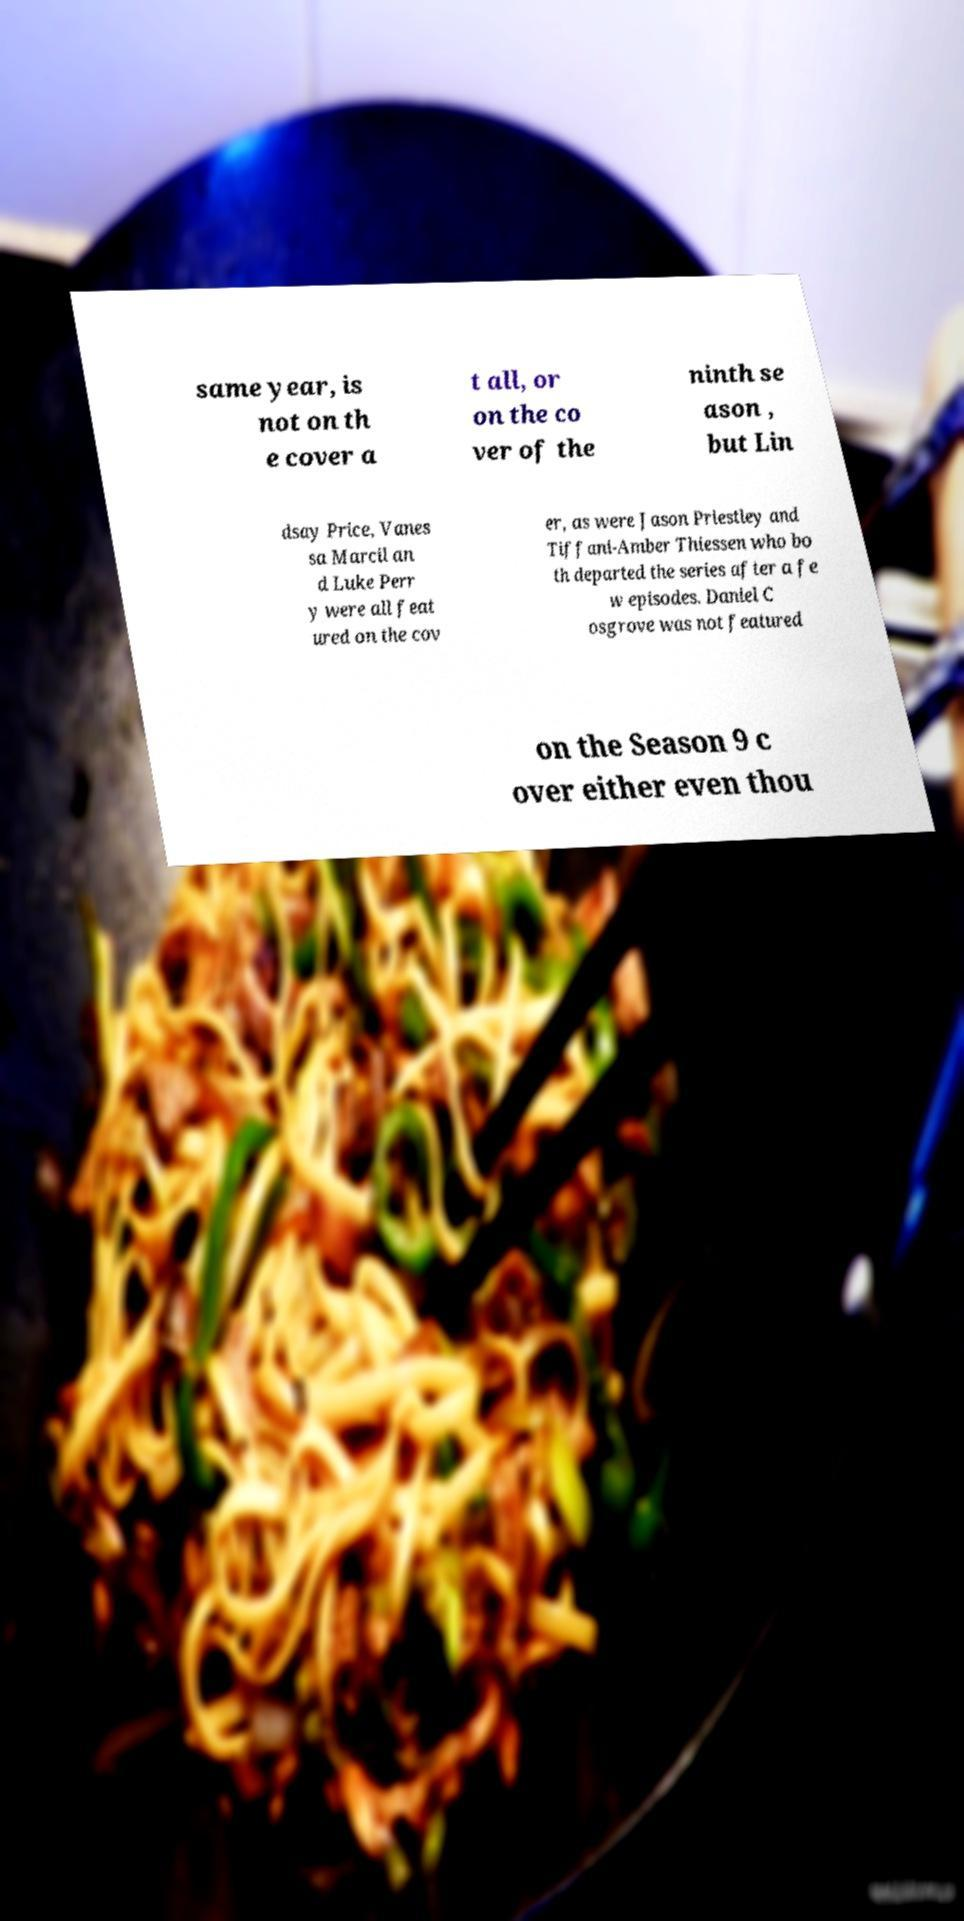Could you assist in decoding the text presented in this image and type it out clearly? same year, is not on th e cover a t all, or on the co ver of the ninth se ason , but Lin dsay Price, Vanes sa Marcil an d Luke Perr y were all feat ured on the cov er, as were Jason Priestley and Tiffani-Amber Thiessen who bo th departed the series after a fe w episodes. Daniel C osgrove was not featured on the Season 9 c over either even thou 